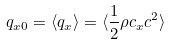<formula> <loc_0><loc_0><loc_500><loc_500>q _ { x 0 } = \langle q _ { x } \rangle = \langle \frac { 1 } { 2 } \rho c _ { x } c ^ { 2 } \rangle</formula> 